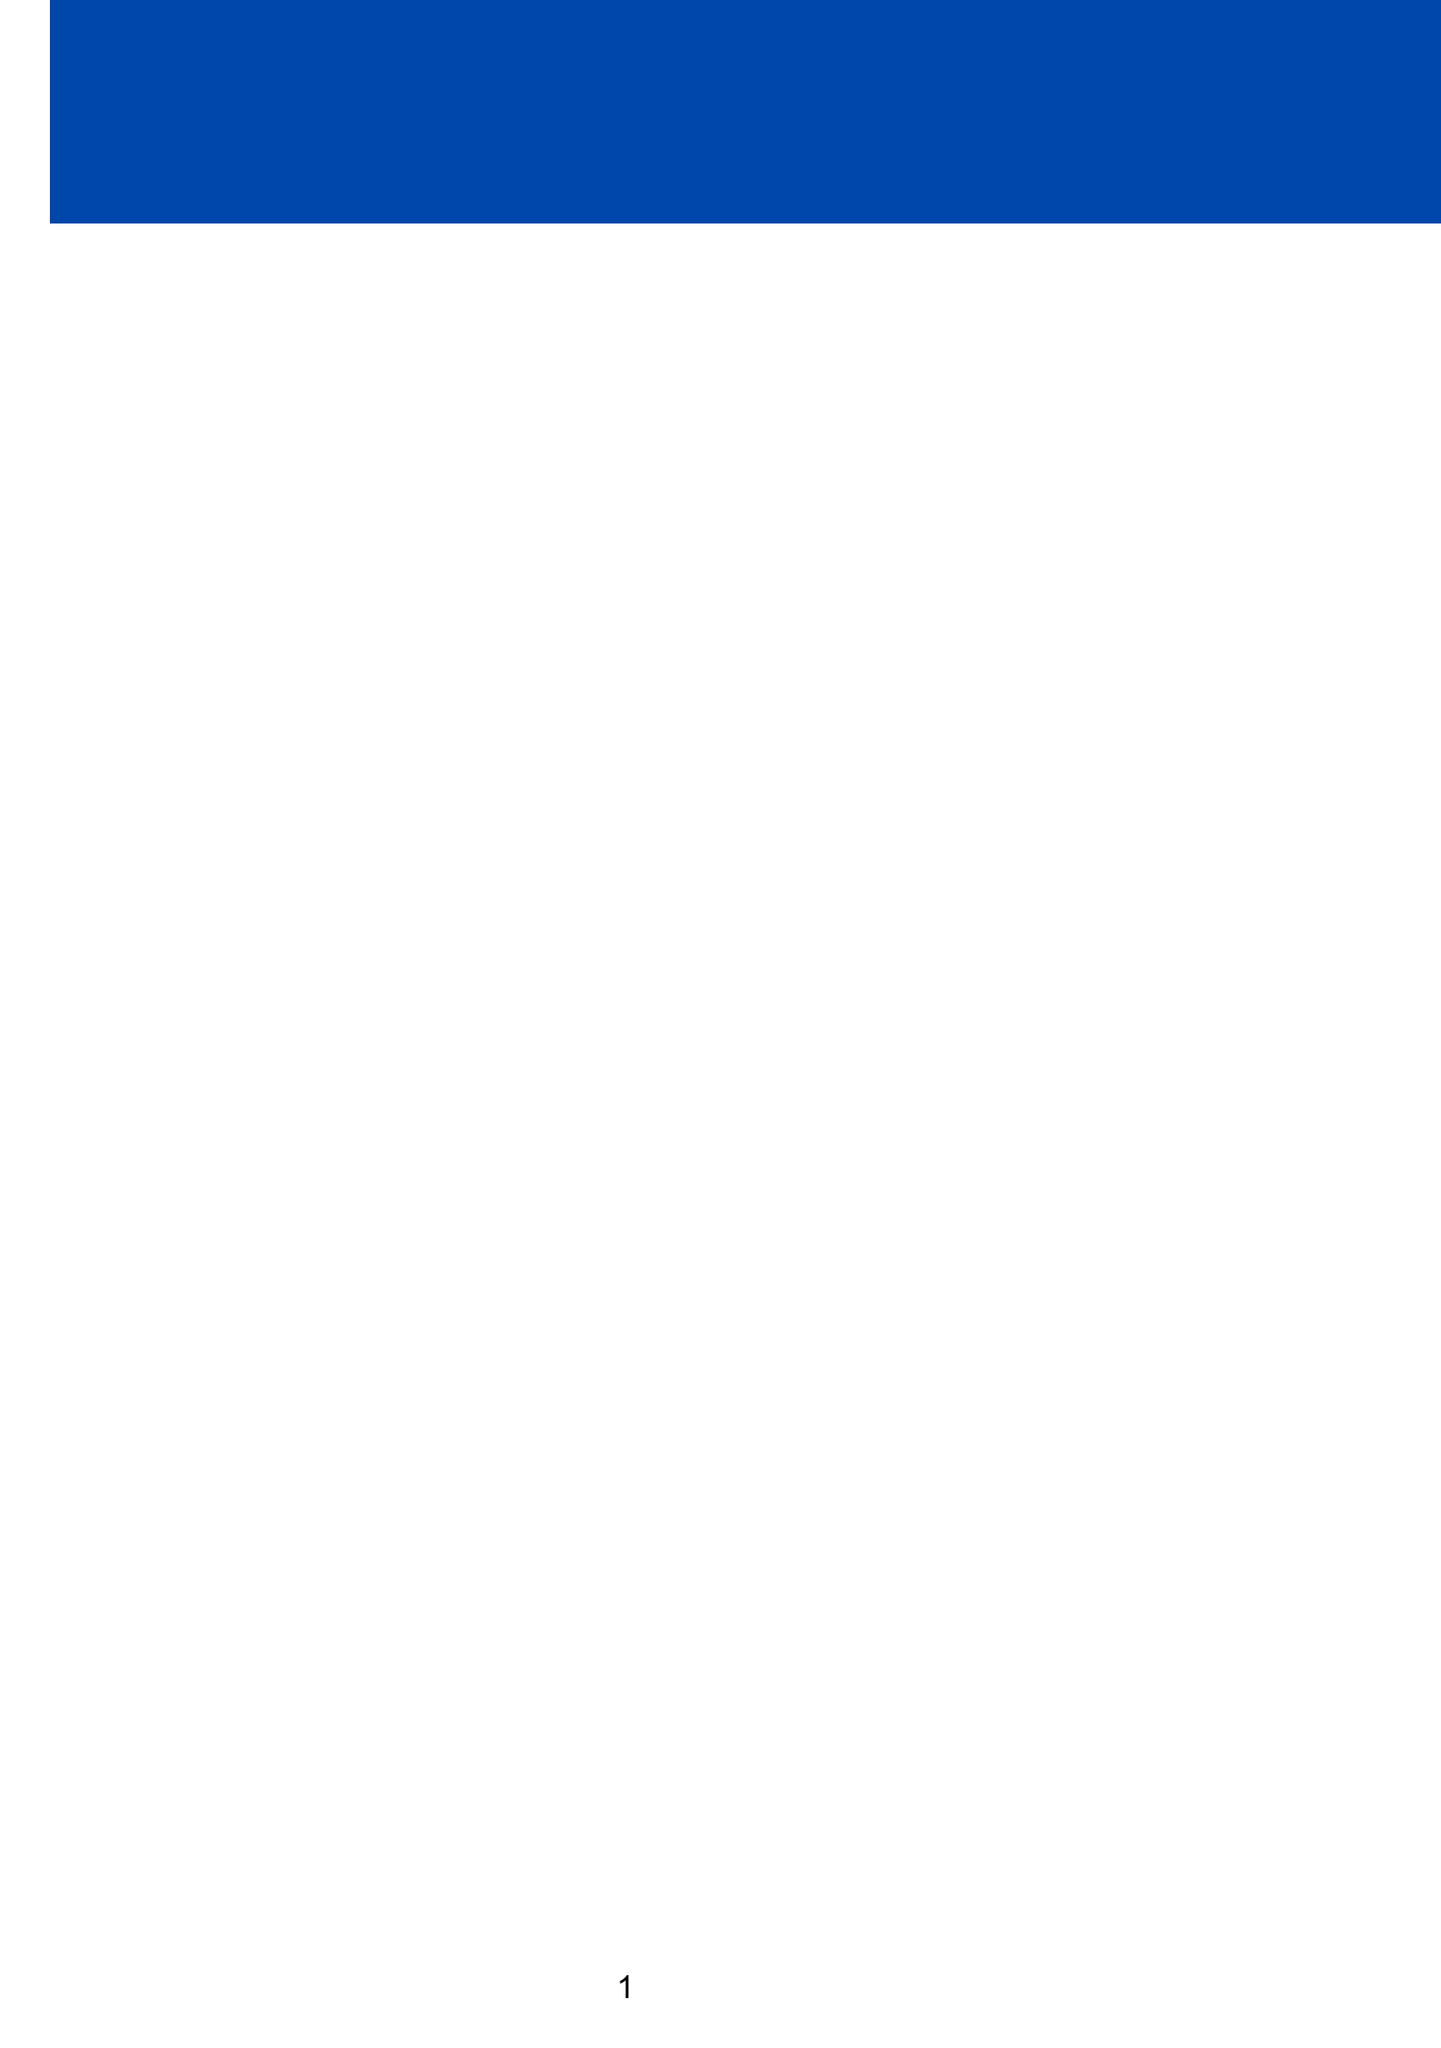What is the name of the event? The name of the event is specified in the document as the "Ultimate Guys-Only Super Bowl LVIII Bash."
Answer: Ultimate Guys-Only Super Bowl LVIII Bash What is the date of the Super Bowl party? The date of the party is included in the event details section, which is February 11, 2024.
Answer: February 11, 2024 Who is the host of the party? The host's name is provided as Mike 'The Bulldog' Johnson in the document.
Answer: Mike 'The Bulldog' Johnson What type of entertainment will be present? The entertainment section lists activities including a Madden NFL 24 tournament, which indicates the kind of entertainment planned.
Answer: Madden NFL 24 tournament What are the consequences for texting a significant other during the game? The document states that anyone caught texting their 'better half' during the game pays a $50 fine, which outlines the consequence.
Answer: $50 fine Is there a dress code for the party? The document explicitly mentions a dress code that includes mandatory team jerseys, indicating the requirement.
Answer: Yes What food item is served from Buffalo Wild Wings? The party menu specifies "Wings from Buffalo Wild Wings," directly stating the food item.
Answer: Wings What must guests do about their shirts after every touchdown? The strict rules state that "Shirts optional after every touchdown," indicating the instruction regarding shirts.
Answer: Optional How many highlights are listed in the party? The party highlights section lists five different highlights, therefore indicating the number.
Answer: Five 